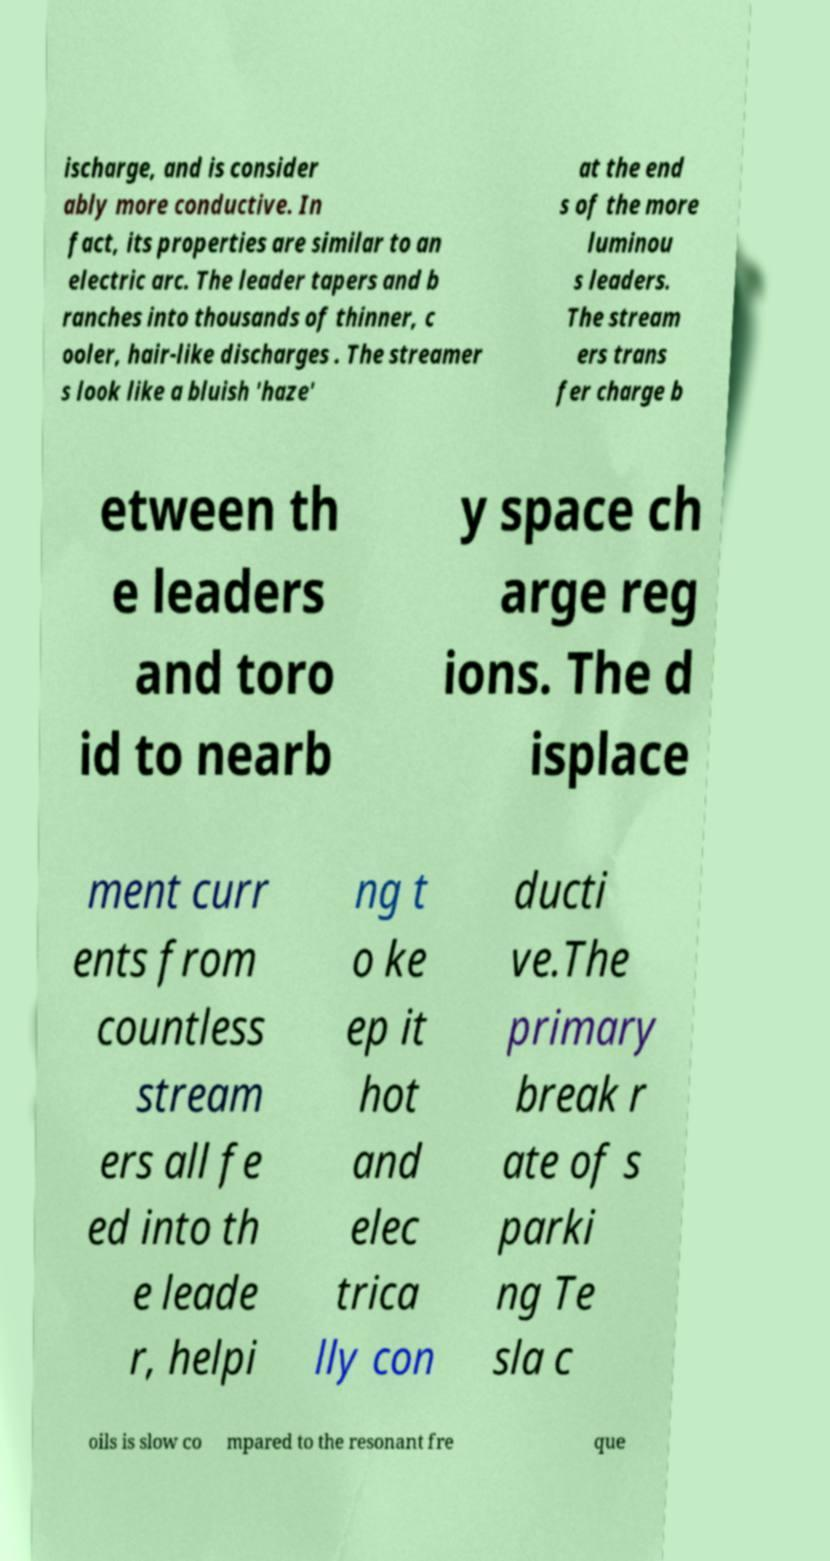What messages or text are displayed in this image? I need them in a readable, typed format. ischarge, and is consider ably more conductive. In fact, its properties are similar to an electric arc. The leader tapers and b ranches into thousands of thinner, c ooler, hair-like discharges . The streamer s look like a bluish 'haze' at the end s of the more luminou s leaders. The stream ers trans fer charge b etween th e leaders and toro id to nearb y space ch arge reg ions. The d isplace ment curr ents from countless stream ers all fe ed into th e leade r, helpi ng t o ke ep it hot and elec trica lly con ducti ve.The primary break r ate of s parki ng Te sla c oils is slow co mpared to the resonant fre que 